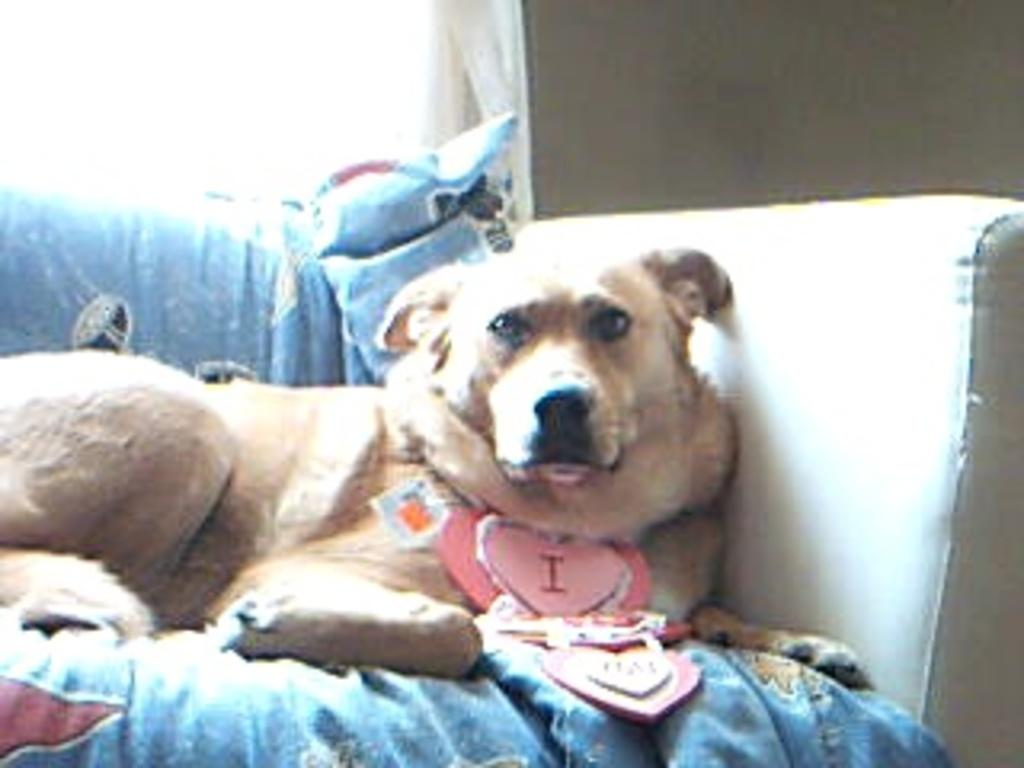What type of animal is in the image? There is a dog in the image. Where is the dog located? The dog is sitting on a sofa. What material can be seen in the image? There is cloth visible in the image. What type of office equipment can be seen in the image? There is no office equipment present in the image; it features a dog sitting on a sofa. How does the dog feel about sitting on the sofa in the image? The image does not provide information about the dog's feelings or emotions. 